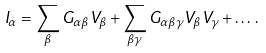Convert formula to latex. <formula><loc_0><loc_0><loc_500><loc_500>I _ { \alpha } = \sum _ { \beta } G _ { \alpha \beta } V _ { \beta } + \sum _ { \beta \gamma } G _ { \alpha \beta \gamma } V _ { \beta } V _ { \gamma } + \dots \, .</formula> 